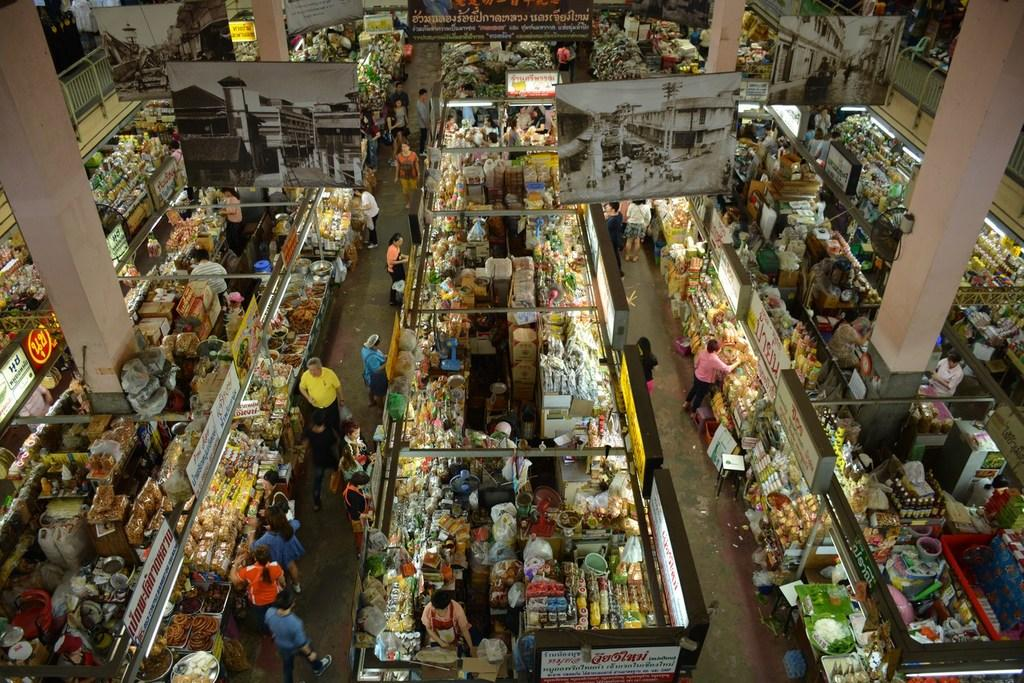Provide a one-sentence caption for the provided image. Overhead view of a market containing banners and aisle markers in a foreign language. 